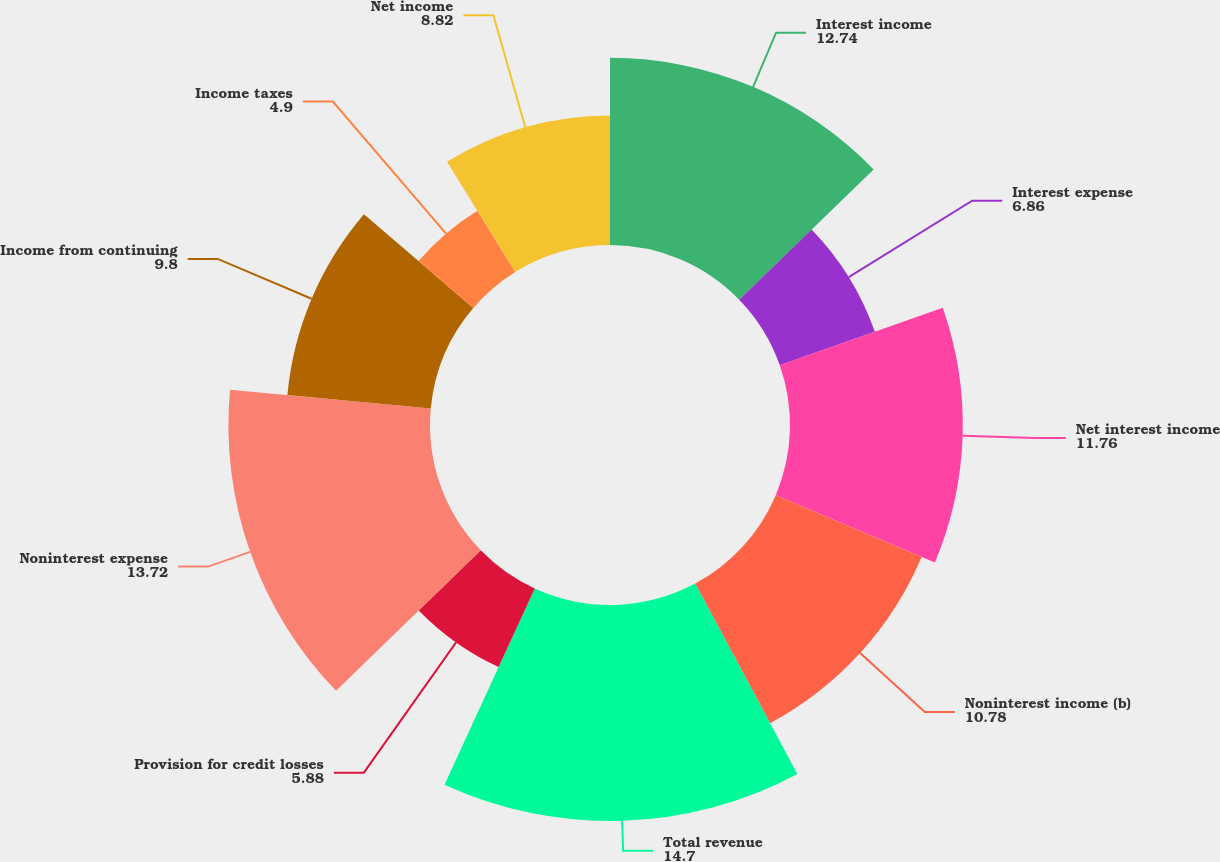<chart> <loc_0><loc_0><loc_500><loc_500><pie_chart><fcel>Interest income<fcel>Interest expense<fcel>Net interest income<fcel>Noninterest income (b)<fcel>Total revenue<fcel>Provision for credit losses<fcel>Noninterest expense<fcel>Income from continuing<fcel>Income taxes<fcel>Net income<nl><fcel>12.74%<fcel>6.86%<fcel>11.76%<fcel>10.78%<fcel>14.7%<fcel>5.88%<fcel>13.72%<fcel>9.8%<fcel>4.9%<fcel>8.82%<nl></chart> 